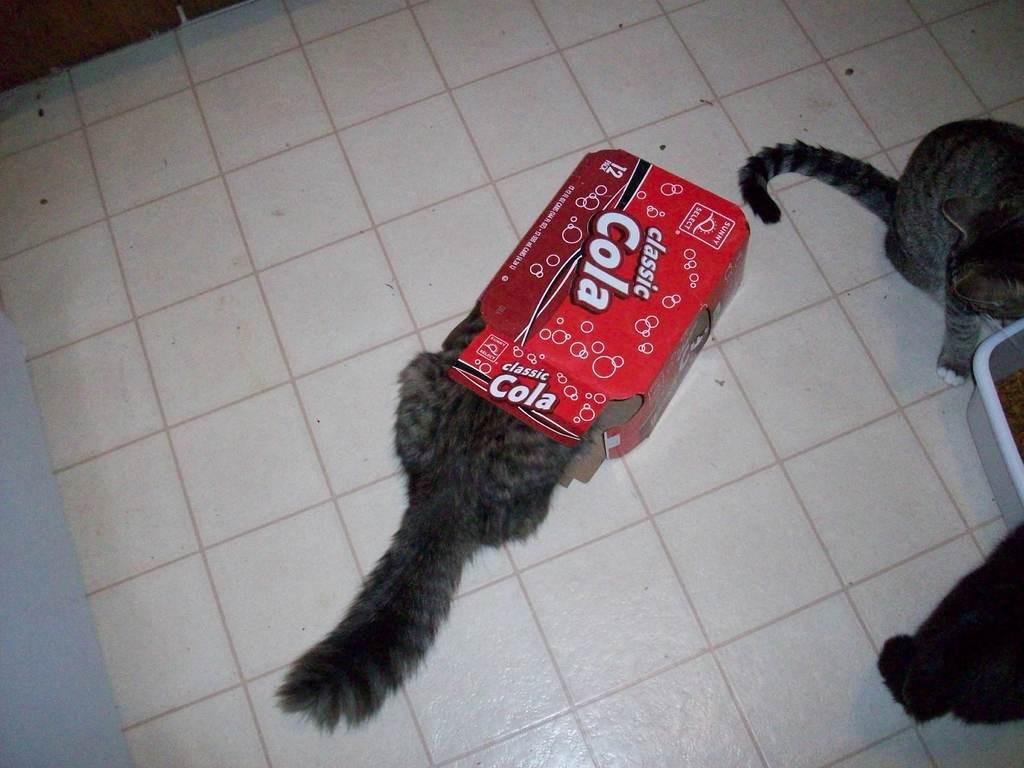How would you summarize this image in a sentence or two? There is a cat in a box and right side of the image we can see cats and container and we can see floor. 